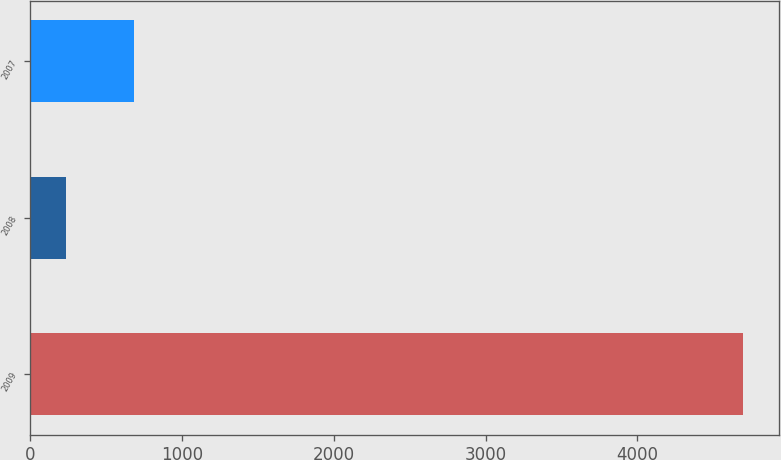<chart> <loc_0><loc_0><loc_500><loc_500><bar_chart><fcel>2009<fcel>2008<fcel>2007<nl><fcel>4698<fcel>236<fcel>682.2<nl></chart> 